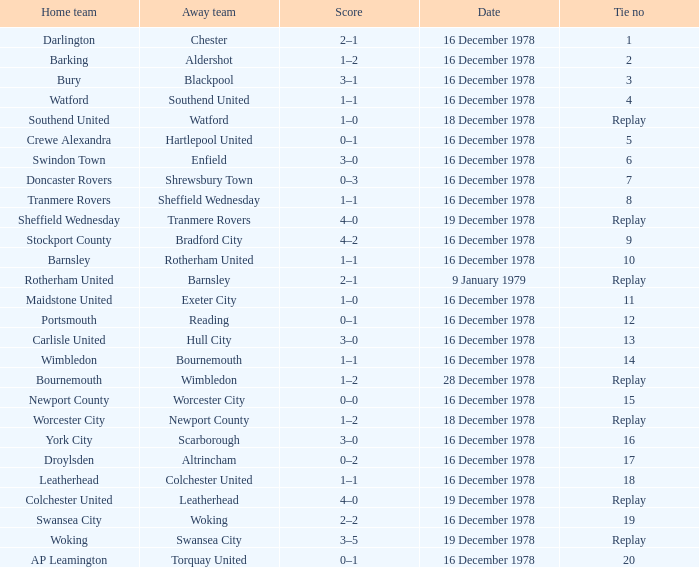What is the tie no for the away team altrincham? 17.0. 